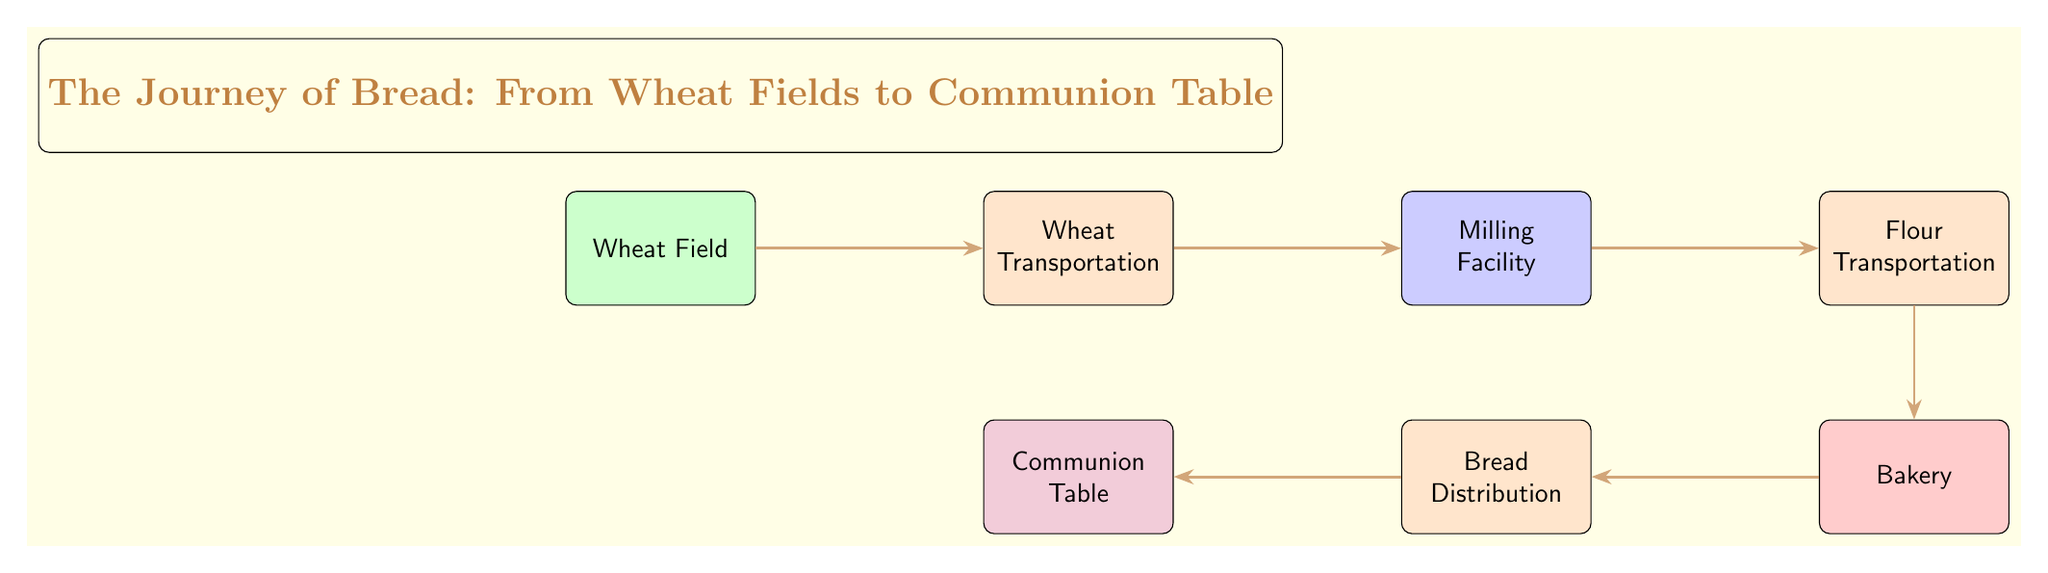What is the first node in the journey of bread? The first node in the diagram is "Wheat Field," as it is positioned at the far left and leads to the next stage in the food chain.
Answer: Wheat Field How many nodes are present in the diagram? By counting each distinct section from "Wheat Field" to "Communion Table," we find there are a total of 6 nodes in the diagram.
Answer: 6 What is the last node in the journey of bread? The last node in the diagram is "Communion Table," which is the final destination of the flow from the earlier stages of the bread-making process.
Answer: Communion Table What is the second node in the process? The second node, following "Wheat Field," is "Wheat Transportation," indicating the first step after harvesting the wheat.
Answer: Wheat Transportation Which node comes after the "Milling Facility"? The node that follows "Milling Facility" in the journey of bread is "Flour Transportation," indicating the next step where the flour is transported after milling.
Answer: Flour Transportation What color is the "Bakery" node? The "Bakery" node is colored red, as indicated in the visual representation, distinguishing it from other stages in the process.
Answer: Red How many transportation stages are there in the journey? There are two distinct transportation stages detailed in the diagram: "Wheat Transportation" and "Flour Transportation."
Answer: 2 What is the relationship between "Bakery" and "Bread Distribution"? "Bakery" directly feeds into "Bread Distribution," indicating that bread is distributed after it has been baked in the bakery.
Answer: Direct What stage follows "Bread Distribution"? The stage that follows "Bread Distribution" in the food chain is "Communion Table," signifying where the bread ultimately ends up for use in communion.
Answer: Communion Table 